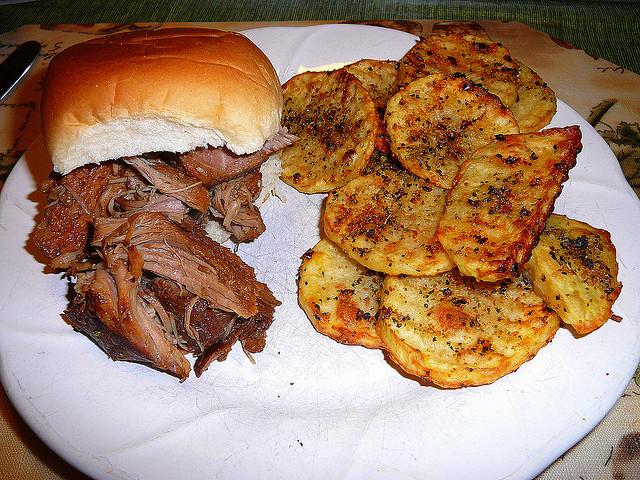The item on the right is most likely a cooked version of what? potatoes 